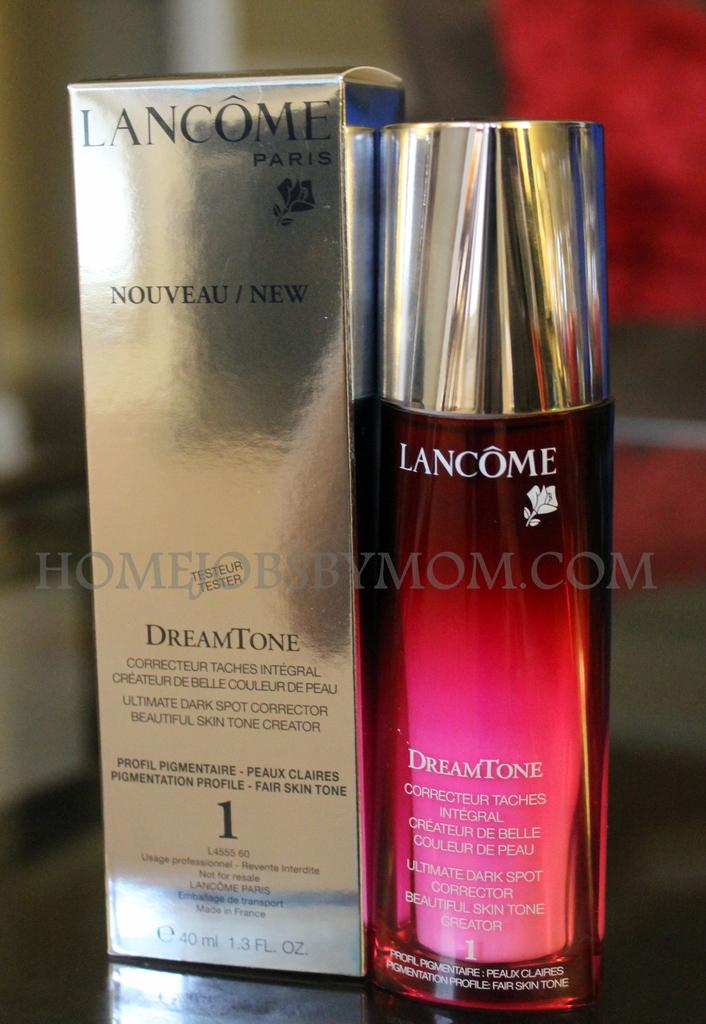What is present on the box in the image? There is text on the box in the image. What is located beside the box? There is a bottle with text beside the box. Can you describe any additional design elements in the image? Yes, there is a watermark in the image. How would you describe the overall appearance of the image? The background of the image is blurred. What type of eggnog is being served in the park in the image? There is no eggnog or park present in the image; it features a box, a bottle, and a watermark on a blurred background. 